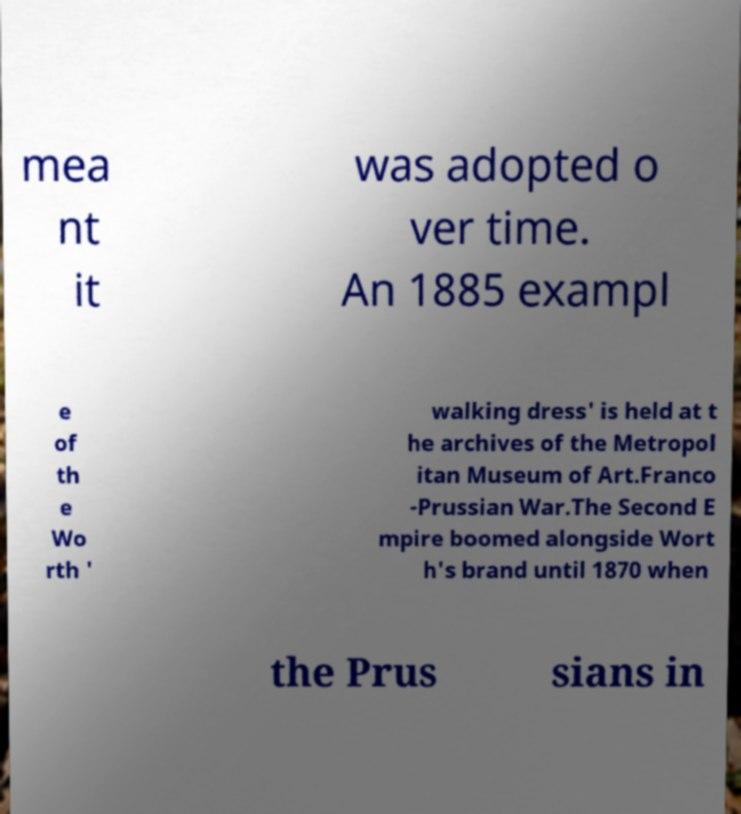For documentation purposes, I need the text within this image transcribed. Could you provide that? mea nt it was adopted o ver time. An 1885 exampl e of th e Wo rth ' walking dress' is held at t he archives of the Metropol itan Museum of Art.Franco -Prussian War.The Second E mpire boomed alongside Wort h's brand until 1870 when the Prus sians in 